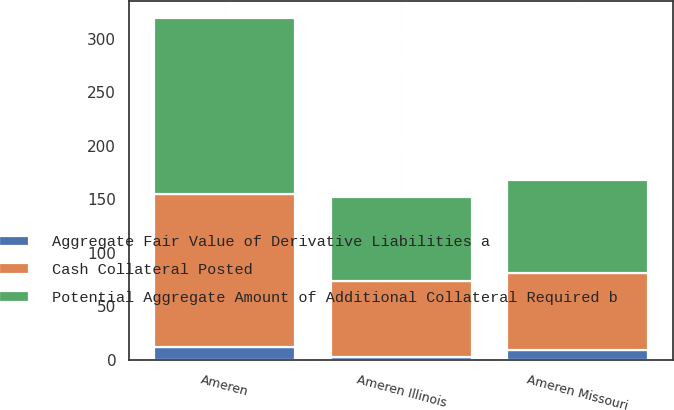Convert chart. <chart><loc_0><loc_0><loc_500><loc_500><stacked_bar_chart><ecel><fcel>Ameren Missouri<fcel>Ameren Illinois<fcel>Ameren<nl><fcel>Potential Aggregate Amount of Additional Collateral Required b<fcel>87<fcel>78<fcel>165<nl><fcel>Aggregate Fair Value of Derivative Liabilities a<fcel>9<fcel>3<fcel>12<nl><fcel>Cash Collateral Posted<fcel>72<fcel>71<fcel>143<nl></chart> 